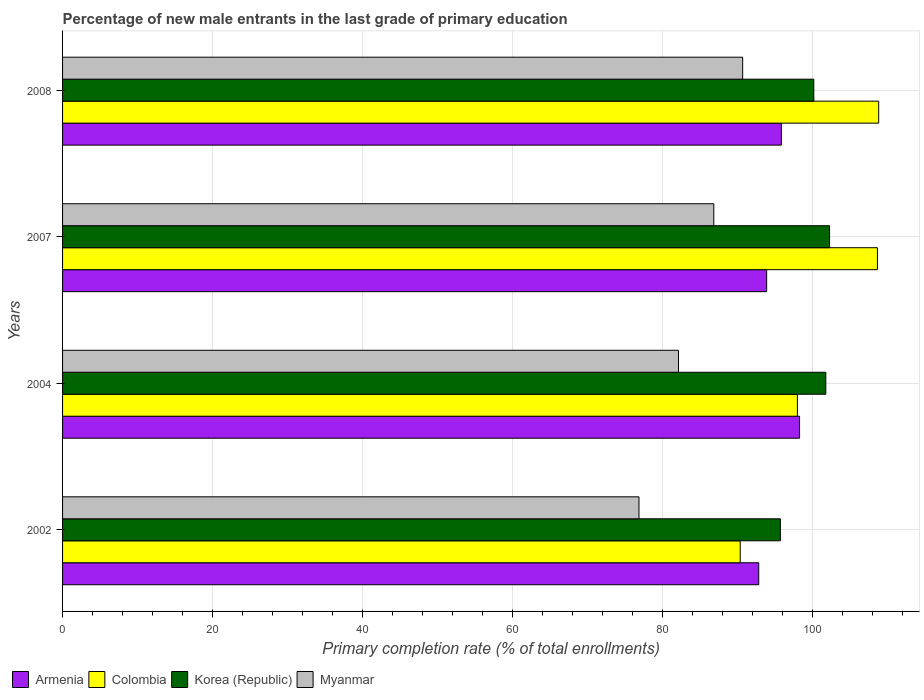How many bars are there on the 3rd tick from the top?
Offer a very short reply. 4. What is the label of the 3rd group of bars from the top?
Make the answer very short. 2004. In how many cases, is the number of bars for a given year not equal to the number of legend labels?
Provide a short and direct response. 0. What is the percentage of new male entrants in Armenia in 2002?
Provide a short and direct response. 92.83. Across all years, what is the maximum percentage of new male entrants in Armenia?
Keep it short and to the point. 98.27. Across all years, what is the minimum percentage of new male entrants in Myanmar?
Your answer should be very brief. 76.86. What is the total percentage of new male entrants in Myanmar in the graph?
Your response must be concise. 336.51. What is the difference between the percentage of new male entrants in Korea (Republic) in 2004 and that in 2008?
Give a very brief answer. 1.6. What is the difference between the percentage of new male entrants in Myanmar in 2004 and the percentage of new male entrants in Colombia in 2007?
Offer a terse response. -26.52. What is the average percentage of new male entrants in Korea (Republic) per year?
Keep it short and to the point. 99.98. In the year 2002, what is the difference between the percentage of new male entrants in Korea (Republic) and percentage of new male entrants in Colombia?
Keep it short and to the point. 5.35. In how many years, is the percentage of new male entrants in Armenia greater than 88 %?
Give a very brief answer. 4. What is the ratio of the percentage of new male entrants in Armenia in 2004 to that in 2007?
Your answer should be very brief. 1.05. What is the difference between the highest and the second highest percentage of new male entrants in Armenia?
Offer a very short reply. 2.43. What is the difference between the highest and the lowest percentage of new male entrants in Armenia?
Your response must be concise. 5.44. Is the sum of the percentage of new male entrants in Myanmar in 2004 and 2008 greater than the maximum percentage of new male entrants in Armenia across all years?
Give a very brief answer. Yes. What does the 4th bar from the top in 2004 represents?
Your response must be concise. Armenia. What does the 1st bar from the bottom in 2004 represents?
Keep it short and to the point. Armenia. How many bars are there?
Offer a very short reply. 16. Are all the bars in the graph horizontal?
Your answer should be very brief. Yes. What is the difference between two consecutive major ticks on the X-axis?
Your answer should be very brief. 20. Does the graph contain any zero values?
Provide a short and direct response. No. Does the graph contain grids?
Give a very brief answer. Yes. How many legend labels are there?
Provide a short and direct response. 4. How are the legend labels stacked?
Make the answer very short. Horizontal. What is the title of the graph?
Give a very brief answer. Percentage of new male entrants in the last grade of primary education. What is the label or title of the X-axis?
Ensure brevity in your answer.  Primary completion rate (% of total enrollments). What is the Primary completion rate (% of total enrollments) in Armenia in 2002?
Your answer should be compact. 92.83. What is the Primary completion rate (% of total enrollments) in Colombia in 2002?
Provide a succinct answer. 90.36. What is the Primary completion rate (% of total enrollments) of Korea (Republic) in 2002?
Your answer should be very brief. 95.71. What is the Primary completion rate (% of total enrollments) of Myanmar in 2002?
Keep it short and to the point. 76.86. What is the Primary completion rate (% of total enrollments) of Armenia in 2004?
Your answer should be compact. 98.27. What is the Primary completion rate (% of total enrollments) in Colombia in 2004?
Ensure brevity in your answer.  97.98. What is the Primary completion rate (% of total enrollments) in Korea (Republic) in 2004?
Provide a succinct answer. 101.77. What is the Primary completion rate (% of total enrollments) in Myanmar in 2004?
Your answer should be compact. 82.13. What is the Primary completion rate (% of total enrollments) in Armenia in 2007?
Ensure brevity in your answer.  93.88. What is the Primary completion rate (% of total enrollments) of Colombia in 2007?
Give a very brief answer. 108.65. What is the Primary completion rate (% of total enrollments) of Korea (Republic) in 2007?
Provide a short and direct response. 102.28. What is the Primary completion rate (% of total enrollments) of Myanmar in 2007?
Give a very brief answer. 86.84. What is the Primary completion rate (% of total enrollments) in Armenia in 2008?
Your response must be concise. 95.84. What is the Primary completion rate (% of total enrollments) of Colombia in 2008?
Your response must be concise. 108.82. What is the Primary completion rate (% of total enrollments) of Korea (Republic) in 2008?
Your response must be concise. 100.17. What is the Primary completion rate (% of total enrollments) of Myanmar in 2008?
Offer a very short reply. 90.69. Across all years, what is the maximum Primary completion rate (% of total enrollments) of Armenia?
Ensure brevity in your answer.  98.27. Across all years, what is the maximum Primary completion rate (% of total enrollments) in Colombia?
Your response must be concise. 108.82. Across all years, what is the maximum Primary completion rate (% of total enrollments) in Korea (Republic)?
Your answer should be very brief. 102.28. Across all years, what is the maximum Primary completion rate (% of total enrollments) in Myanmar?
Offer a terse response. 90.69. Across all years, what is the minimum Primary completion rate (% of total enrollments) in Armenia?
Your answer should be compact. 92.83. Across all years, what is the minimum Primary completion rate (% of total enrollments) of Colombia?
Provide a short and direct response. 90.36. Across all years, what is the minimum Primary completion rate (% of total enrollments) in Korea (Republic)?
Provide a succinct answer. 95.71. Across all years, what is the minimum Primary completion rate (% of total enrollments) in Myanmar?
Your response must be concise. 76.86. What is the total Primary completion rate (% of total enrollments) in Armenia in the graph?
Keep it short and to the point. 380.83. What is the total Primary completion rate (% of total enrollments) of Colombia in the graph?
Your response must be concise. 405.82. What is the total Primary completion rate (% of total enrollments) of Korea (Republic) in the graph?
Provide a short and direct response. 399.94. What is the total Primary completion rate (% of total enrollments) in Myanmar in the graph?
Ensure brevity in your answer.  336.51. What is the difference between the Primary completion rate (% of total enrollments) of Armenia in 2002 and that in 2004?
Make the answer very short. -5.44. What is the difference between the Primary completion rate (% of total enrollments) in Colombia in 2002 and that in 2004?
Give a very brief answer. -7.62. What is the difference between the Primary completion rate (% of total enrollments) in Korea (Republic) in 2002 and that in 2004?
Keep it short and to the point. -6.06. What is the difference between the Primary completion rate (% of total enrollments) of Myanmar in 2002 and that in 2004?
Give a very brief answer. -5.27. What is the difference between the Primary completion rate (% of total enrollments) of Armenia in 2002 and that in 2007?
Make the answer very short. -1.05. What is the difference between the Primary completion rate (% of total enrollments) of Colombia in 2002 and that in 2007?
Provide a succinct answer. -18.29. What is the difference between the Primary completion rate (% of total enrollments) of Korea (Republic) in 2002 and that in 2007?
Provide a succinct answer. -6.56. What is the difference between the Primary completion rate (% of total enrollments) of Myanmar in 2002 and that in 2007?
Provide a succinct answer. -9.98. What is the difference between the Primary completion rate (% of total enrollments) in Armenia in 2002 and that in 2008?
Provide a short and direct response. -3.01. What is the difference between the Primary completion rate (% of total enrollments) in Colombia in 2002 and that in 2008?
Give a very brief answer. -18.46. What is the difference between the Primary completion rate (% of total enrollments) of Korea (Republic) in 2002 and that in 2008?
Your response must be concise. -4.46. What is the difference between the Primary completion rate (% of total enrollments) in Myanmar in 2002 and that in 2008?
Ensure brevity in your answer.  -13.83. What is the difference between the Primary completion rate (% of total enrollments) of Armenia in 2004 and that in 2007?
Offer a terse response. 4.39. What is the difference between the Primary completion rate (% of total enrollments) in Colombia in 2004 and that in 2007?
Keep it short and to the point. -10.67. What is the difference between the Primary completion rate (% of total enrollments) in Korea (Republic) in 2004 and that in 2007?
Make the answer very short. -0.5. What is the difference between the Primary completion rate (% of total enrollments) of Myanmar in 2004 and that in 2007?
Provide a short and direct response. -4.71. What is the difference between the Primary completion rate (% of total enrollments) of Armenia in 2004 and that in 2008?
Your response must be concise. 2.43. What is the difference between the Primary completion rate (% of total enrollments) in Colombia in 2004 and that in 2008?
Offer a terse response. -10.84. What is the difference between the Primary completion rate (% of total enrollments) of Korea (Republic) in 2004 and that in 2008?
Provide a short and direct response. 1.6. What is the difference between the Primary completion rate (% of total enrollments) of Myanmar in 2004 and that in 2008?
Give a very brief answer. -8.56. What is the difference between the Primary completion rate (% of total enrollments) of Armenia in 2007 and that in 2008?
Provide a succinct answer. -1.96. What is the difference between the Primary completion rate (% of total enrollments) of Colombia in 2007 and that in 2008?
Provide a succinct answer. -0.17. What is the difference between the Primary completion rate (% of total enrollments) in Korea (Republic) in 2007 and that in 2008?
Offer a terse response. 2.1. What is the difference between the Primary completion rate (% of total enrollments) in Myanmar in 2007 and that in 2008?
Give a very brief answer. -3.85. What is the difference between the Primary completion rate (% of total enrollments) of Armenia in 2002 and the Primary completion rate (% of total enrollments) of Colombia in 2004?
Keep it short and to the point. -5.15. What is the difference between the Primary completion rate (% of total enrollments) in Armenia in 2002 and the Primary completion rate (% of total enrollments) in Korea (Republic) in 2004?
Provide a succinct answer. -8.94. What is the difference between the Primary completion rate (% of total enrollments) in Armenia in 2002 and the Primary completion rate (% of total enrollments) in Myanmar in 2004?
Provide a succinct answer. 10.7. What is the difference between the Primary completion rate (% of total enrollments) of Colombia in 2002 and the Primary completion rate (% of total enrollments) of Korea (Republic) in 2004?
Offer a terse response. -11.41. What is the difference between the Primary completion rate (% of total enrollments) of Colombia in 2002 and the Primary completion rate (% of total enrollments) of Myanmar in 2004?
Make the answer very short. 8.23. What is the difference between the Primary completion rate (% of total enrollments) of Korea (Republic) in 2002 and the Primary completion rate (% of total enrollments) of Myanmar in 2004?
Offer a very short reply. 13.58. What is the difference between the Primary completion rate (% of total enrollments) in Armenia in 2002 and the Primary completion rate (% of total enrollments) in Colombia in 2007?
Offer a terse response. -15.82. What is the difference between the Primary completion rate (% of total enrollments) in Armenia in 2002 and the Primary completion rate (% of total enrollments) in Korea (Republic) in 2007?
Your answer should be compact. -9.45. What is the difference between the Primary completion rate (% of total enrollments) of Armenia in 2002 and the Primary completion rate (% of total enrollments) of Myanmar in 2007?
Keep it short and to the point. 5.99. What is the difference between the Primary completion rate (% of total enrollments) in Colombia in 2002 and the Primary completion rate (% of total enrollments) in Korea (Republic) in 2007?
Offer a terse response. -11.92. What is the difference between the Primary completion rate (% of total enrollments) of Colombia in 2002 and the Primary completion rate (% of total enrollments) of Myanmar in 2007?
Your response must be concise. 3.52. What is the difference between the Primary completion rate (% of total enrollments) of Korea (Republic) in 2002 and the Primary completion rate (% of total enrollments) of Myanmar in 2007?
Your answer should be compact. 8.88. What is the difference between the Primary completion rate (% of total enrollments) of Armenia in 2002 and the Primary completion rate (% of total enrollments) of Colombia in 2008?
Offer a very short reply. -15.99. What is the difference between the Primary completion rate (% of total enrollments) in Armenia in 2002 and the Primary completion rate (% of total enrollments) in Korea (Republic) in 2008?
Provide a short and direct response. -7.34. What is the difference between the Primary completion rate (% of total enrollments) of Armenia in 2002 and the Primary completion rate (% of total enrollments) of Myanmar in 2008?
Offer a terse response. 2.14. What is the difference between the Primary completion rate (% of total enrollments) of Colombia in 2002 and the Primary completion rate (% of total enrollments) of Korea (Republic) in 2008?
Offer a terse response. -9.81. What is the difference between the Primary completion rate (% of total enrollments) of Colombia in 2002 and the Primary completion rate (% of total enrollments) of Myanmar in 2008?
Your answer should be compact. -0.33. What is the difference between the Primary completion rate (% of total enrollments) of Korea (Republic) in 2002 and the Primary completion rate (% of total enrollments) of Myanmar in 2008?
Give a very brief answer. 5.03. What is the difference between the Primary completion rate (% of total enrollments) of Armenia in 2004 and the Primary completion rate (% of total enrollments) of Colombia in 2007?
Offer a very short reply. -10.38. What is the difference between the Primary completion rate (% of total enrollments) in Armenia in 2004 and the Primary completion rate (% of total enrollments) in Korea (Republic) in 2007?
Provide a succinct answer. -4. What is the difference between the Primary completion rate (% of total enrollments) of Armenia in 2004 and the Primary completion rate (% of total enrollments) of Myanmar in 2007?
Give a very brief answer. 11.44. What is the difference between the Primary completion rate (% of total enrollments) in Colombia in 2004 and the Primary completion rate (% of total enrollments) in Korea (Republic) in 2007?
Keep it short and to the point. -4.29. What is the difference between the Primary completion rate (% of total enrollments) in Colombia in 2004 and the Primary completion rate (% of total enrollments) in Myanmar in 2007?
Your response must be concise. 11.15. What is the difference between the Primary completion rate (% of total enrollments) of Korea (Republic) in 2004 and the Primary completion rate (% of total enrollments) of Myanmar in 2007?
Make the answer very short. 14.94. What is the difference between the Primary completion rate (% of total enrollments) of Armenia in 2004 and the Primary completion rate (% of total enrollments) of Colombia in 2008?
Your answer should be very brief. -10.55. What is the difference between the Primary completion rate (% of total enrollments) in Armenia in 2004 and the Primary completion rate (% of total enrollments) in Korea (Republic) in 2008?
Provide a succinct answer. -1.9. What is the difference between the Primary completion rate (% of total enrollments) in Armenia in 2004 and the Primary completion rate (% of total enrollments) in Myanmar in 2008?
Your answer should be very brief. 7.59. What is the difference between the Primary completion rate (% of total enrollments) in Colombia in 2004 and the Primary completion rate (% of total enrollments) in Korea (Republic) in 2008?
Keep it short and to the point. -2.19. What is the difference between the Primary completion rate (% of total enrollments) in Colombia in 2004 and the Primary completion rate (% of total enrollments) in Myanmar in 2008?
Provide a short and direct response. 7.3. What is the difference between the Primary completion rate (% of total enrollments) in Korea (Republic) in 2004 and the Primary completion rate (% of total enrollments) in Myanmar in 2008?
Provide a short and direct response. 11.09. What is the difference between the Primary completion rate (% of total enrollments) of Armenia in 2007 and the Primary completion rate (% of total enrollments) of Colombia in 2008?
Provide a succinct answer. -14.94. What is the difference between the Primary completion rate (% of total enrollments) of Armenia in 2007 and the Primary completion rate (% of total enrollments) of Korea (Republic) in 2008?
Offer a terse response. -6.29. What is the difference between the Primary completion rate (% of total enrollments) in Armenia in 2007 and the Primary completion rate (% of total enrollments) in Myanmar in 2008?
Offer a very short reply. 3.2. What is the difference between the Primary completion rate (% of total enrollments) in Colombia in 2007 and the Primary completion rate (% of total enrollments) in Korea (Republic) in 2008?
Your response must be concise. 8.48. What is the difference between the Primary completion rate (% of total enrollments) of Colombia in 2007 and the Primary completion rate (% of total enrollments) of Myanmar in 2008?
Offer a very short reply. 17.97. What is the difference between the Primary completion rate (% of total enrollments) in Korea (Republic) in 2007 and the Primary completion rate (% of total enrollments) in Myanmar in 2008?
Give a very brief answer. 11.59. What is the average Primary completion rate (% of total enrollments) in Armenia per year?
Make the answer very short. 95.21. What is the average Primary completion rate (% of total enrollments) in Colombia per year?
Ensure brevity in your answer.  101.46. What is the average Primary completion rate (% of total enrollments) in Korea (Republic) per year?
Ensure brevity in your answer.  99.98. What is the average Primary completion rate (% of total enrollments) of Myanmar per year?
Offer a terse response. 84.13. In the year 2002, what is the difference between the Primary completion rate (% of total enrollments) of Armenia and Primary completion rate (% of total enrollments) of Colombia?
Make the answer very short. 2.47. In the year 2002, what is the difference between the Primary completion rate (% of total enrollments) in Armenia and Primary completion rate (% of total enrollments) in Korea (Republic)?
Your answer should be very brief. -2.88. In the year 2002, what is the difference between the Primary completion rate (% of total enrollments) in Armenia and Primary completion rate (% of total enrollments) in Myanmar?
Keep it short and to the point. 15.97. In the year 2002, what is the difference between the Primary completion rate (% of total enrollments) of Colombia and Primary completion rate (% of total enrollments) of Korea (Republic)?
Keep it short and to the point. -5.35. In the year 2002, what is the difference between the Primary completion rate (% of total enrollments) in Colombia and Primary completion rate (% of total enrollments) in Myanmar?
Offer a terse response. 13.5. In the year 2002, what is the difference between the Primary completion rate (% of total enrollments) in Korea (Republic) and Primary completion rate (% of total enrollments) in Myanmar?
Keep it short and to the point. 18.85. In the year 2004, what is the difference between the Primary completion rate (% of total enrollments) of Armenia and Primary completion rate (% of total enrollments) of Colombia?
Provide a succinct answer. 0.29. In the year 2004, what is the difference between the Primary completion rate (% of total enrollments) of Armenia and Primary completion rate (% of total enrollments) of Korea (Republic)?
Provide a short and direct response. -3.5. In the year 2004, what is the difference between the Primary completion rate (% of total enrollments) of Armenia and Primary completion rate (% of total enrollments) of Myanmar?
Make the answer very short. 16.14. In the year 2004, what is the difference between the Primary completion rate (% of total enrollments) in Colombia and Primary completion rate (% of total enrollments) in Korea (Republic)?
Ensure brevity in your answer.  -3.79. In the year 2004, what is the difference between the Primary completion rate (% of total enrollments) in Colombia and Primary completion rate (% of total enrollments) in Myanmar?
Offer a very short reply. 15.85. In the year 2004, what is the difference between the Primary completion rate (% of total enrollments) in Korea (Republic) and Primary completion rate (% of total enrollments) in Myanmar?
Provide a short and direct response. 19.64. In the year 2007, what is the difference between the Primary completion rate (% of total enrollments) of Armenia and Primary completion rate (% of total enrollments) of Colombia?
Offer a terse response. -14.77. In the year 2007, what is the difference between the Primary completion rate (% of total enrollments) in Armenia and Primary completion rate (% of total enrollments) in Korea (Republic)?
Keep it short and to the point. -8.39. In the year 2007, what is the difference between the Primary completion rate (% of total enrollments) of Armenia and Primary completion rate (% of total enrollments) of Myanmar?
Your answer should be very brief. 7.05. In the year 2007, what is the difference between the Primary completion rate (% of total enrollments) of Colombia and Primary completion rate (% of total enrollments) of Korea (Republic)?
Your answer should be very brief. 6.38. In the year 2007, what is the difference between the Primary completion rate (% of total enrollments) in Colombia and Primary completion rate (% of total enrollments) in Myanmar?
Keep it short and to the point. 21.82. In the year 2007, what is the difference between the Primary completion rate (% of total enrollments) of Korea (Republic) and Primary completion rate (% of total enrollments) of Myanmar?
Offer a very short reply. 15.44. In the year 2008, what is the difference between the Primary completion rate (% of total enrollments) in Armenia and Primary completion rate (% of total enrollments) in Colombia?
Your answer should be very brief. -12.98. In the year 2008, what is the difference between the Primary completion rate (% of total enrollments) of Armenia and Primary completion rate (% of total enrollments) of Korea (Republic)?
Make the answer very short. -4.33. In the year 2008, what is the difference between the Primary completion rate (% of total enrollments) in Armenia and Primary completion rate (% of total enrollments) in Myanmar?
Ensure brevity in your answer.  5.16. In the year 2008, what is the difference between the Primary completion rate (% of total enrollments) of Colombia and Primary completion rate (% of total enrollments) of Korea (Republic)?
Give a very brief answer. 8.65. In the year 2008, what is the difference between the Primary completion rate (% of total enrollments) of Colombia and Primary completion rate (% of total enrollments) of Myanmar?
Offer a very short reply. 18.14. In the year 2008, what is the difference between the Primary completion rate (% of total enrollments) of Korea (Republic) and Primary completion rate (% of total enrollments) of Myanmar?
Your answer should be very brief. 9.49. What is the ratio of the Primary completion rate (% of total enrollments) of Armenia in 2002 to that in 2004?
Provide a succinct answer. 0.94. What is the ratio of the Primary completion rate (% of total enrollments) in Colombia in 2002 to that in 2004?
Give a very brief answer. 0.92. What is the ratio of the Primary completion rate (% of total enrollments) in Korea (Republic) in 2002 to that in 2004?
Provide a succinct answer. 0.94. What is the ratio of the Primary completion rate (% of total enrollments) of Myanmar in 2002 to that in 2004?
Provide a succinct answer. 0.94. What is the ratio of the Primary completion rate (% of total enrollments) in Armenia in 2002 to that in 2007?
Offer a terse response. 0.99. What is the ratio of the Primary completion rate (% of total enrollments) in Colombia in 2002 to that in 2007?
Provide a succinct answer. 0.83. What is the ratio of the Primary completion rate (% of total enrollments) in Korea (Republic) in 2002 to that in 2007?
Provide a succinct answer. 0.94. What is the ratio of the Primary completion rate (% of total enrollments) of Myanmar in 2002 to that in 2007?
Your answer should be very brief. 0.89. What is the ratio of the Primary completion rate (% of total enrollments) in Armenia in 2002 to that in 2008?
Keep it short and to the point. 0.97. What is the ratio of the Primary completion rate (% of total enrollments) in Colombia in 2002 to that in 2008?
Your response must be concise. 0.83. What is the ratio of the Primary completion rate (% of total enrollments) of Korea (Republic) in 2002 to that in 2008?
Offer a terse response. 0.96. What is the ratio of the Primary completion rate (% of total enrollments) of Myanmar in 2002 to that in 2008?
Ensure brevity in your answer.  0.85. What is the ratio of the Primary completion rate (% of total enrollments) of Armenia in 2004 to that in 2007?
Keep it short and to the point. 1.05. What is the ratio of the Primary completion rate (% of total enrollments) of Colombia in 2004 to that in 2007?
Offer a very short reply. 0.9. What is the ratio of the Primary completion rate (% of total enrollments) in Korea (Republic) in 2004 to that in 2007?
Make the answer very short. 1. What is the ratio of the Primary completion rate (% of total enrollments) of Myanmar in 2004 to that in 2007?
Offer a very short reply. 0.95. What is the ratio of the Primary completion rate (% of total enrollments) in Armenia in 2004 to that in 2008?
Provide a short and direct response. 1.03. What is the ratio of the Primary completion rate (% of total enrollments) in Colombia in 2004 to that in 2008?
Provide a succinct answer. 0.9. What is the ratio of the Primary completion rate (% of total enrollments) of Myanmar in 2004 to that in 2008?
Offer a terse response. 0.91. What is the ratio of the Primary completion rate (% of total enrollments) in Armenia in 2007 to that in 2008?
Ensure brevity in your answer.  0.98. What is the ratio of the Primary completion rate (% of total enrollments) of Korea (Republic) in 2007 to that in 2008?
Offer a very short reply. 1.02. What is the ratio of the Primary completion rate (% of total enrollments) of Myanmar in 2007 to that in 2008?
Make the answer very short. 0.96. What is the difference between the highest and the second highest Primary completion rate (% of total enrollments) in Armenia?
Keep it short and to the point. 2.43. What is the difference between the highest and the second highest Primary completion rate (% of total enrollments) in Colombia?
Provide a succinct answer. 0.17. What is the difference between the highest and the second highest Primary completion rate (% of total enrollments) of Korea (Republic)?
Make the answer very short. 0.5. What is the difference between the highest and the second highest Primary completion rate (% of total enrollments) of Myanmar?
Ensure brevity in your answer.  3.85. What is the difference between the highest and the lowest Primary completion rate (% of total enrollments) of Armenia?
Your response must be concise. 5.44. What is the difference between the highest and the lowest Primary completion rate (% of total enrollments) of Colombia?
Your answer should be very brief. 18.46. What is the difference between the highest and the lowest Primary completion rate (% of total enrollments) in Korea (Republic)?
Offer a very short reply. 6.56. What is the difference between the highest and the lowest Primary completion rate (% of total enrollments) of Myanmar?
Offer a terse response. 13.83. 